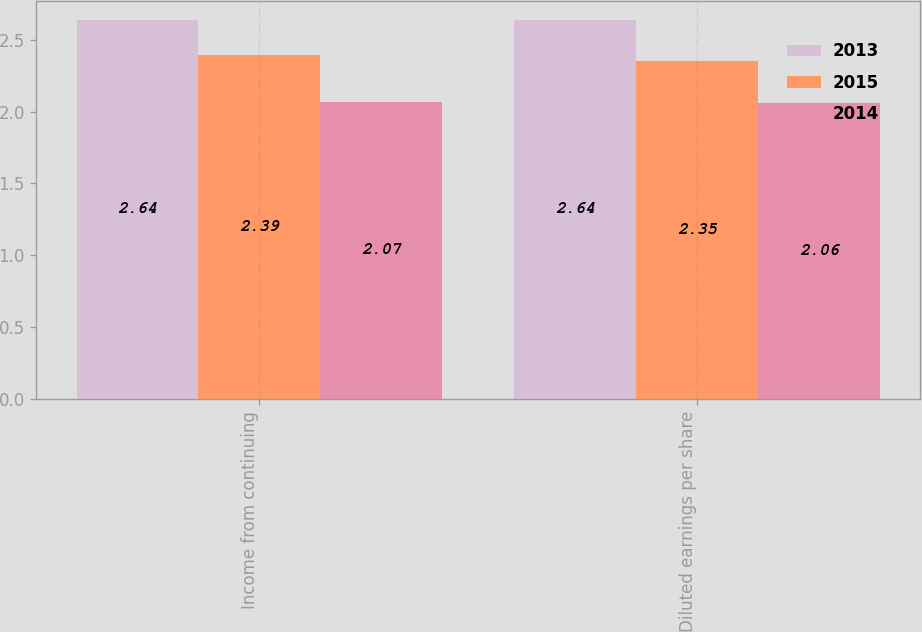<chart> <loc_0><loc_0><loc_500><loc_500><stacked_bar_chart><ecel><fcel>Income from continuing<fcel>Diluted earnings per share<nl><fcel>2013<fcel>2.64<fcel>2.64<nl><fcel>2015<fcel>2.39<fcel>2.35<nl><fcel>2014<fcel>2.07<fcel>2.06<nl></chart> 